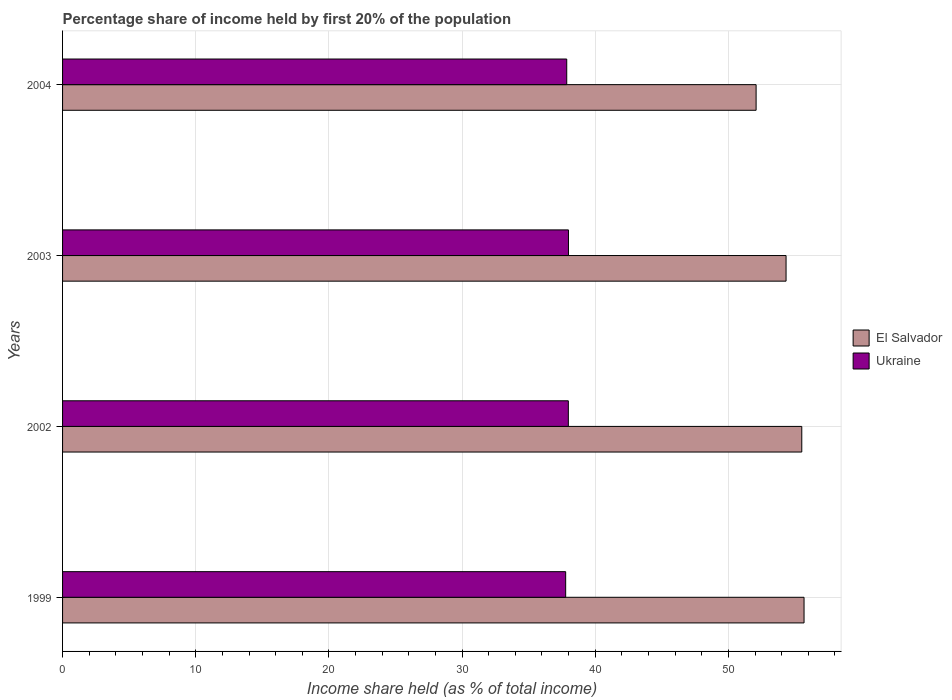How many different coloured bars are there?
Keep it short and to the point. 2. Are the number of bars per tick equal to the number of legend labels?
Offer a very short reply. Yes. How many bars are there on the 4th tick from the bottom?
Provide a succinct answer. 2. What is the label of the 3rd group of bars from the top?
Your answer should be very brief. 2002. What is the share of income held by first 20% of the population in El Salvador in 2004?
Keep it short and to the point. 52.08. Across all years, what is the maximum share of income held by first 20% of the population in Ukraine?
Your answer should be very brief. 37.99. Across all years, what is the minimum share of income held by first 20% of the population in El Salvador?
Give a very brief answer. 52.08. In which year was the share of income held by first 20% of the population in Ukraine maximum?
Offer a very short reply. 2003. What is the total share of income held by first 20% of the population in El Salvador in the graph?
Ensure brevity in your answer.  217.6. What is the difference between the share of income held by first 20% of the population in El Salvador in 1999 and that in 2002?
Give a very brief answer. 0.17. What is the difference between the share of income held by first 20% of the population in El Salvador in 1999 and the share of income held by first 20% of the population in Ukraine in 2002?
Give a very brief answer. 17.7. What is the average share of income held by first 20% of the population in Ukraine per year?
Your answer should be compact. 37.9. In the year 2002, what is the difference between the share of income held by first 20% of the population in El Salvador and share of income held by first 20% of the population in Ukraine?
Offer a very short reply. 17.53. In how many years, is the share of income held by first 20% of the population in El Salvador greater than 26 %?
Your answer should be compact. 4. What is the ratio of the share of income held by first 20% of the population in Ukraine in 1999 to that in 2002?
Your answer should be very brief. 0.99. Is the share of income held by first 20% of the population in Ukraine in 1999 less than that in 2003?
Ensure brevity in your answer.  Yes. Is the difference between the share of income held by first 20% of the population in El Salvador in 2003 and 2004 greater than the difference between the share of income held by first 20% of the population in Ukraine in 2003 and 2004?
Offer a very short reply. Yes. What is the difference between the highest and the second highest share of income held by first 20% of the population in Ukraine?
Offer a very short reply. 0.01. What is the difference between the highest and the lowest share of income held by first 20% of the population in Ukraine?
Make the answer very short. 0.21. Is the sum of the share of income held by first 20% of the population in Ukraine in 2002 and 2004 greater than the maximum share of income held by first 20% of the population in El Salvador across all years?
Give a very brief answer. Yes. What does the 1st bar from the top in 2002 represents?
Make the answer very short. Ukraine. What does the 2nd bar from the bottom in 2004 represents?
Your answer should be compact. Ukraine. Are the values on the major ticks of X-axis written in scientific E-notation?
Offer a terse response. No. Does the graph contain grids?
Your answer should be compact. Yes. How many legend labels are there?
Offer a very short reply. 2. How are the legend labels stacked?
Your response must be concise. Vertical. What is the title of the graph?
Give a very brief answer. Percentage share of income held by first 20% of the population. Does "Lesotho" appear as one of the legend labels in the graph?
Offer a terse response. No. What is the label or title of the X-axis?
Keep it short and to the point. Income share held (as % of total income). What is the Income share held (as % of total income) in El Salvador in 1999?
Offer a very short reply. 55.68. What is the Income share held (as % of total income) in Ukraine in 1999?
Your response must be concise. 37.78. What is the Income share held (as % of total income) of El Salvador in 2002?
Make the answer very short. 55.51. What is the Income share held (as % of total income) in Ukraine in 2002?
Your response must be concise. 37.98. What is the Income share held (as % of total income) in El Salvador in 2003?
Provide a succinct answer. 54.33. What is the Income share held (as % of total income) in Ukraine in 2003?
Make the answer very short. 37.99. What is the Income share held (as % of total income) in El Salvador in 2004?
Your response must be concise. 52.08. What is the Income share held (as % of total income) in Ukraine in 2004?
Your answer should be very brief. 37.86. Across all years, what is the maximum Income share held (as % of total income) in El Salvador?
Your answer should be very brief. 55.68. Across all years, what is the maximum Income share held (as % of total income) of Ukraine?
Offer a very short reply. 37.99. Across all years, what is the minimum Income share held (as % of total income) of El Salvador?
Offer a very short reply. 52.08. Across all years, what is the minimum Income share held (as % of total income) of Ukraine?
Provide a succinct answer. 37.78. What is the total Income share held (as % of total income) of El Salvador in the graph?
Offer a very short reply. 217.6. What is the total Income share held (as % of total income) of Ukraine in the graph?
Ensure brevity in your answer.  151.61. What is the difference between the Income share held (as % of total income) in El Salvador in 1999 and that in 2002?
Your answer should be very brief. 0.17. What is the difference between the Income share held (as % of total income) of Ukraine in 1999 and that in 2002?
Your answer should be compact. -0.2. What is the difference between the Income share held (as % of total income) of El Salvador in 1999 and that in 2003?
Make the answer very short. 1.35. What is the difference between the Income share held (as % of total income) of Ukraine in 1999 and that in 2003?
Ensure brevity in your answer.  -0.21. What is the difference between the Income share held (as % of total income) of El Salvador in 1999 and that in 2004?
Your answer should be compact. 3.6. What is the difference between the Income share held (as % of total income) of Ukraine in 1999 and that in 2004?
Your response must be concise. -0.08. What is the difference between the Income share held (as % of total income) in El Salvador in 2002 and that in 2003?
Offer a terse response. 1.18. What is the difference between the Income share held (as % of total income) in Ukraine in 2002 and that in 2003?
Your answer should be very brief. -0.01. What is the difference between the Income share held (as % of total income) in El Salvador in 2002 and that in 2004?
Give a very brief answer. 3.43. What is the difference between the Income share held (as % of total income) of Ukraine in 2002 and that in 2004?
Offer a very short reply. 0.12. What is the difference between the Income share held (as % of total income) in El Salvador in 2003 and that in 2004?
Offer a terse response. 2.25. What is the difference between the Income share held (as % of total income) in Ukraine in 2003 and that in 2004?
Your response must be concise. 0.13. What is the difference between the Income share held (as % of total income) of El Salvador in 1999 and the Income share held (as % of total income) of Ukraine in 2003?
Provide a succinct answer. 17.69. What is the difference between the Income share held (as % of total income) in El Salvador in 1999 and the Income share held (as % of total income) in Ukraine in 2004?
Offer a terse response. 17.82. What is the difference between the Income share held (as % of total income) of El Salvador in 2002 and the Income share held (as % of total income) of Ukraine in 2003?
Give a very brief answer. 17.52. What is the difference between the Income share held (as % of total income) in El Salvador in 2002 and the Income share held (as % of total income) in Ukraine in 2004?
Keep it short and to the point. 17.65. What is the difference between the Income share held (as % of total income) in El Salvador in 2003 and the Income share held (as % of total income) in Ukraine in 2004?
Ensure brevity in your answer.  16.47. What is the average Income share held (as % of total income) of El Salvador per year?
Provide a short and direct response. 54.4. What is the average Income share held (as % of total income) of Ukraine per year?
Make the answer very short. 37.9. In the year 2002, what is the difference between the Income share held (as % of total income) in El Salvador and Income share held (as % of total income) in Ukraine?
Provide a short and direct response. 17.53. In the year 2003, what is the difference between the Income share held (as % of total income) of El Salvador and Income share held (as % of total income) of Ukraine?
Offer a very short reply. 16.34. In the year 2004, what is the difference between the Income share held (as % of total income) in El Salvador and Income share held (as % of total income) in Ukraine?
Ensure brevity in your answer.  14.22. What is the ratio of the Income share held (as % of total income) of El Salvador in 1999 to that in 2002?
Offer a terse response. 1. What is the ratio of the Income share held (as % of total income) of El Salvador in 1999 to that in 2003?
Provide a succinct answer. 1.02. What is the ratio of the Income share held (as % of total income) of El Salvador in 1999 to that in 2004?
Give a very brief answer. 1.07. What is the ratio of the Income share held (as % of total income) of Ukraine in 1999 to that in 2004?
Provide a short and direct response. 1. What is the ratio of the Income share held (as % of total income) of El Salvador in 2002 to that in 2003?
Make the answer very short. 1.02. What is the ratio of the Income share held (as % of total income) in El Salvador in 2002 to that in 2004?
Offer a very short reply. 1.07. What is the ratio of the Income share held (as % of total income) of Ukraine in 2002 to that in 2004?
Your answer should be very brief. 1. What is the ratio of the Income share held (as % of total income) in El Salvador in 2003 to that in 2004?
Give a very brief answer. 1.04. What is the difference between the highest and the second highest Income share held (as % of total income) of El Salvador?
Provide a succinct answer. 0.17. What is the difference between the highest and the lowest Income share held (as % of total income) of Ukraine?
Your answer should be very brief. 0.21. 